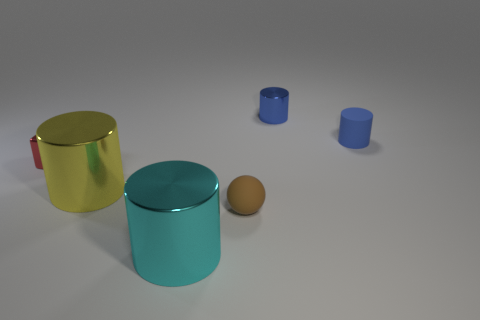Subtract all brown cubes. How many blue cylinders are left? 2 Subtract all small blue metallic cylinders. How many cylinders are left? 3 Subtract all cyan cylinders. How many cylinders are left? 3 Add 3 small matte things. How many objects exist? 9 Subtract all cubes. How many objects are left? 5 Subtract all blue rubber balls. Subtract all tiny blue things. How many objects are left? 4 Add 4 brown matte things. How many brown matte things are left? 5 Add 5 tiny gray rubber cylinders. How many tiny gray rubber cylinders exist? 5 Subtract 0 cyan blocks. How many objects are left? 6 Subtract all purple cylinders. Subtract all brown spheres. How many cylinders are left? 4 